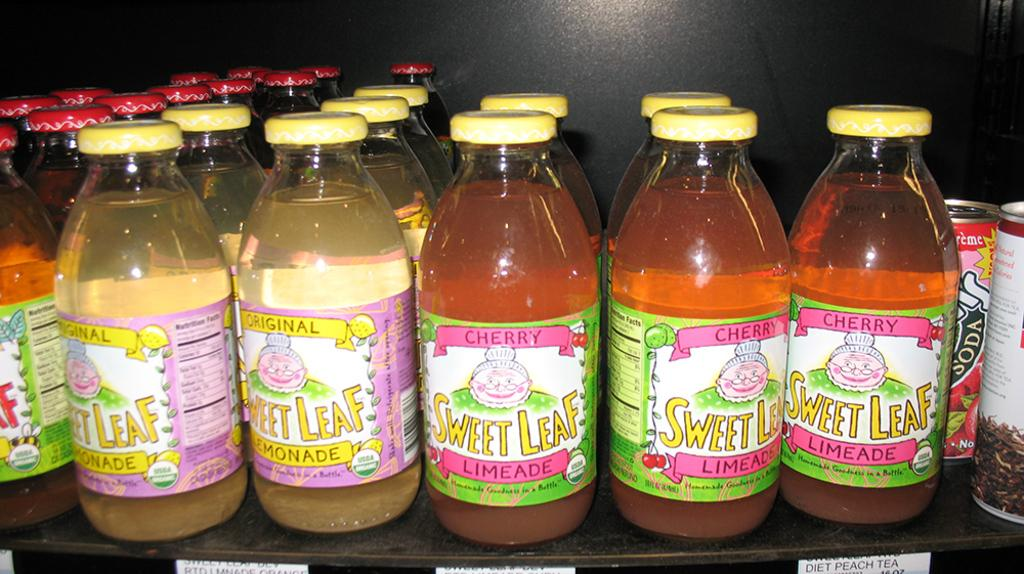<image>
Share a concise interpretation of the image provided. Rows of glass bottles of Sweet Leaf lemonade and limeade 